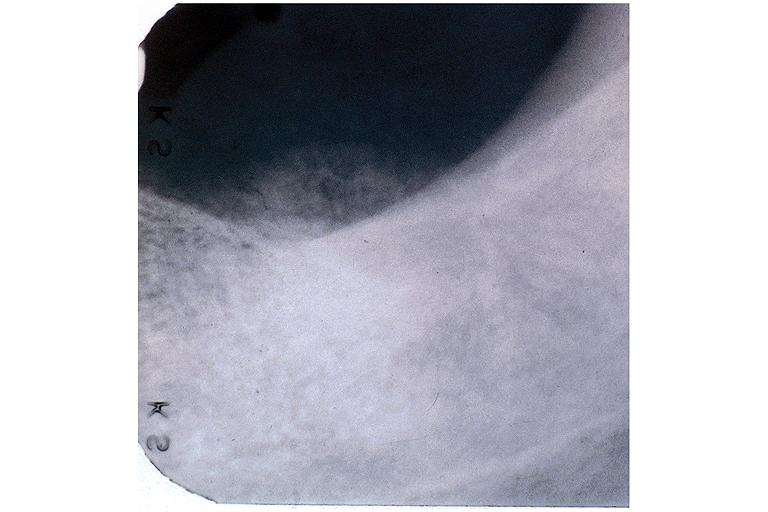does male reproductive show osteosarcoma?
Answer the question using a single word or phrase. No 